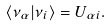<formula> <loc_0><loc_0><loc_500><loc_500>\langle \nu _ { \alpha } | \nu _ { i } \rangle = U _ { \alpha i } .</formula> 